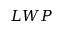<formula> <loc_0><loc_0><loc_500><loc_500>L W P</formula> 